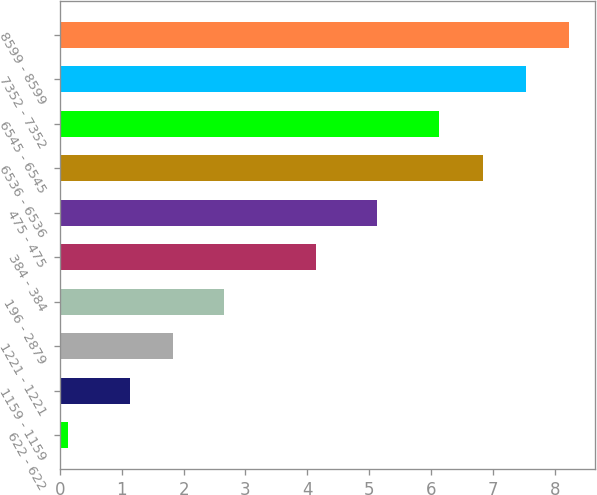Convert chart. <chart><loc_0><loc_0><loc_500><loc_500><bar_chart><fcel>622 - 622<fcel>1159 - 1159<fcel>1221 - 1221<fcel>196 - 2879<fcel>384 - 384<fcel>475 - 475<fcel>6536 - 6536<fcel>6545 - 6545<fcel>7352 - 7352<fcel>8599 - 8599<nl><fcel>0.13<fcel>1.13<fcel>1.83<fcel>2.65<fcel>4.14<fcel>5.13<fcel>6.83<fcel>6.13<fcel>7.53<fcel>8.23<nl></chart> 